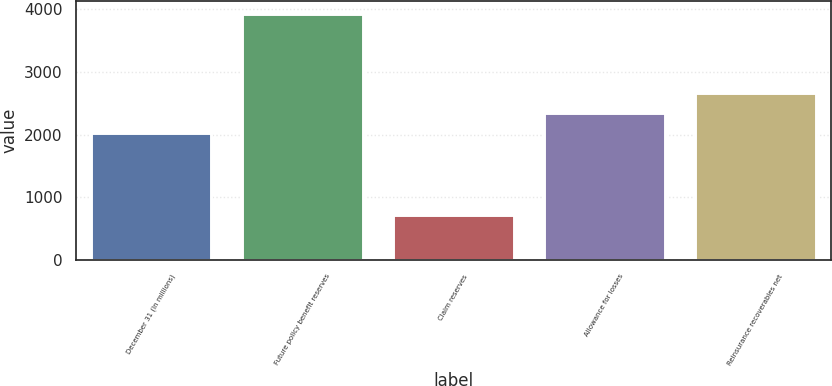Convert chart to OTSL. <chart><loc_0><loc_0><loc_500><loc_500><bar_chart><fcel>December 31 (In millions)<fcel>Future policy benefit reserves<fcel>Claim reserves<fcel>Allowance for losses<fcel>Reinsurance recoverables net<nl><fcel>2017<fcel>3928<fcel>715<fcel>2338.3<fcel>2659.6<nl></chart> 